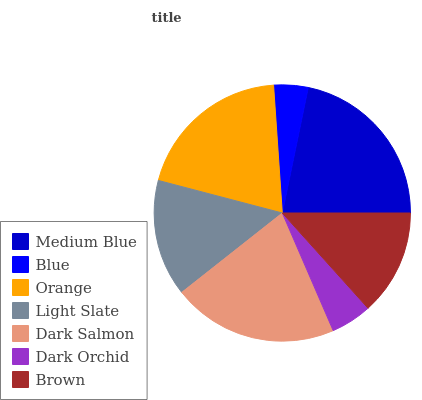Is Blue the minimum?
Answer yes or no. Yes. Is Medium Blue the maximum?
Answer yes or no. Yes. Is Orange the minimum?
Answer yes or no. No. Is Orange the maximum?
Answer yes or no. No. Is Orange greater than Blue?
Answer yes or no. Yes. Is Blue less than Orange?
Answer yes or no. Yes. Is Blue greater than Orange?
Answer yes or no. No. Is Orange less than Blue?
Answer yes or no. No. Is Light Slate the high median?
Answer yes or no. Yes. Is Light Slate the low median?
Answer yes or no. Yes. Is Dark Orchid the high median?
Answer yes or no. No. Is Orange the low median?
Answer yes or no. No. 